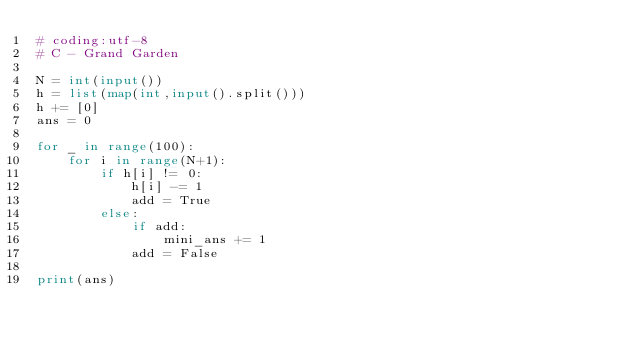<code> <loc_0><loc_0><loc_500><loc_500><_Python_># coding:utf-8
# C - Grand Garden

N = int(input())
h = list(map(int,input().split()))
h += [0]
ans = 0

for _ in range(100):
    for i in range(N+1):
        if h[i] != 0:
            h[i] -= 1
            add = True
        else:
            if add:
                mini_ans += 1
            add = False

print(ans)</code> 